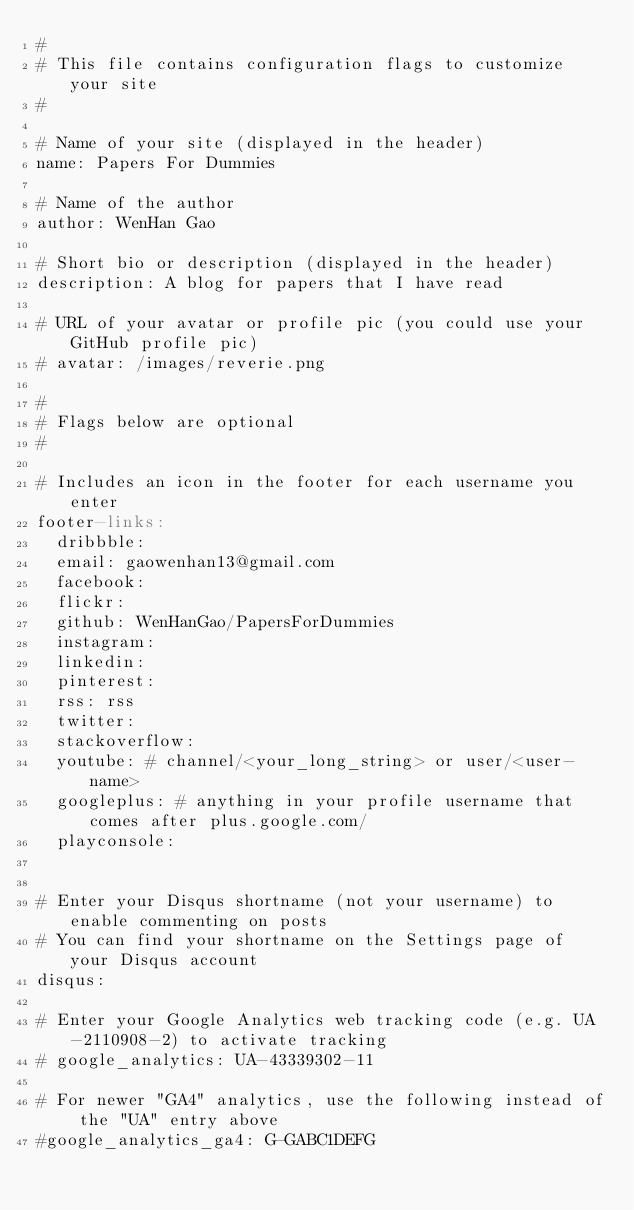<code> <loc_0><loc_0><loc_500><loc_500><_YAML_>#
# This file contains configuration flags to customize your site
#

# Name of your site (displayed in the header)
name: Papers For Dummies

# Name of the author
author: WenHan Gao

# Short bio or description (displayed in the header)
description: A blog for papers that I have read

# URL of your avatar or profile pic (you could use your GitHub profile pic)
# avatar: /images/reverie.png

#
# Flags below are optional
#

# Includes an icon in the footer for each username you enter
footer-links:
  dribbble:
  email: gaowenhan13@gmail.com
  facebook:
  flickr:
  github: WenHanGao/PapersForDummies
  instagram:
  linkedin: 
  pinterest:
  rss: rss
  twitter: 
  stackoverflow: 
  youtube: # channel/<your_long_string> or user/<user-name>
  googleplus: # anything in your profile username that comes after plus.google.com/
  playconsole:


# Enter your Disqus shortname (not your username) to enable commenting on posts
# You can find your shortname on the Settings page of your Disqus account
disqus: 

# Enter your Google Analytics web tracking code (e.g. UA-2110908-2) to activate tracking
# google_analytics: UA-43339302-11

# For newer "GA4" analytics, use the following instead of the "UA" entry above
#google_analytics_ga4: G-GABC1DEFG
</code> 